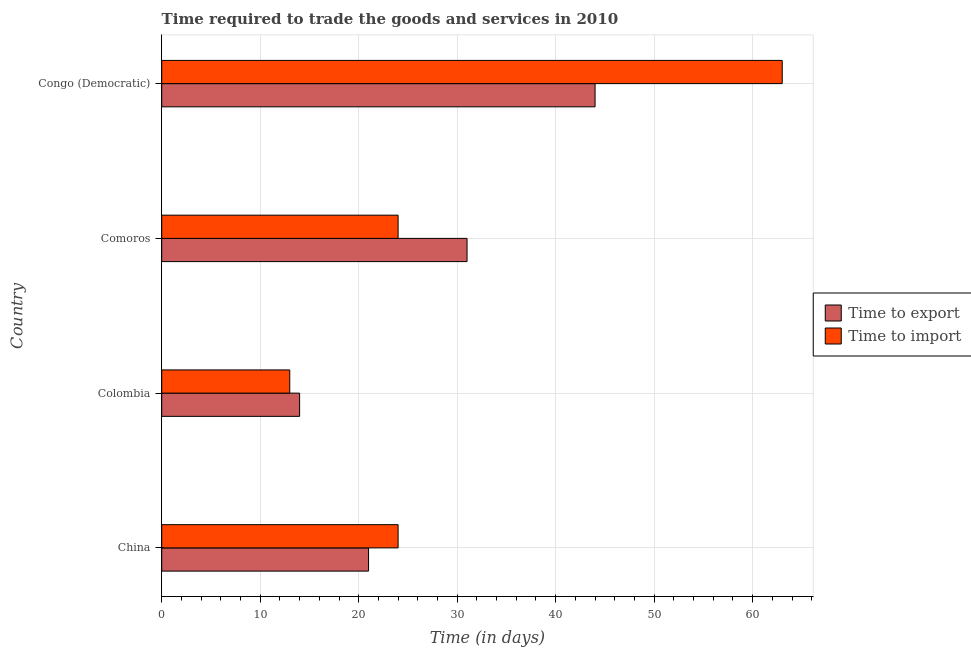How many different coloured bars are there?
Your answer should be compact. 2. Are the number of bars on each tick of the Y-axis equal?
Offer a very short reply. Yes. How many bars are there on the 1st tick from the top?
Ensure brevity in your answer.  2. In how many cases, is the number of bars for a given country not equal to the number of legend labels?
Your response must be concise. 0. Across all countries, what is the maximum time to export?
Give a very brief answer. 44. In which country was the time to export maximum?
Provide a short and direct response. Congo (Democratic). What is the total time to import in the graph?
Make the answer very short. 124. What is the difference between the time to export in Colombia and the time to import in Comoros?
Offer a terse response. -10. What is the ratio of the time to export in China to that in Comoros?
Offer a terse response. 0.68. Is the time to import in China less than that in Congo (Democratic)?
Offer a very short reply. Yes. Is the difference between the time to export in Colombia and Comoros greater than the difference between the time to import in Colombia and Comoros?
Provide a succinct answer. No. What is the difference between the highest and the second highest time to export?
Your answer should be compact. 13. What does the 1st bar from the top in Congo (Democratic) represents?
Provide a succinct answer. Time to import. What does the 1st bar from the bottom in Colombia represents?
Provide a short and direct response. Time to export. How many bars are there?
Keep it short and to the point. 8. Are all the bars in the graph horizontal?
Your answer should be very brief. Yes. How many countries are there in the graph?
Your response must be concise. 4. Does the graph contain grids?
Give a very brief answer. Yes. Where does the legend appear in the graph?
Your answer should be very brief. Center right. How are the legend labels stacked?
Your response must be concise. Vertical. What is the title of the graph?
Your answer should be very brief. Time required to trade the goods and services in 2010. Does "Girls" appear as one of the legend labels in the graph?
Your response must be concise. No. What is the label or title of the X-axis?
Offer a terse response. Time (in days). What is the Time (in days) in Time to import in China?
Your answer should be compact. 24. What is the Time (in days) of Time to export in Colombia?
Give a very brief answer. 14. What is the Time (in days) of Time to import in Colombia?
Offer a terse response. 13. What is the Time (in days) in Time to import in Comoros?
Make the answer very short. 24. What is the Time (in days) in Time to import in Congo (Democratic)?
Make the answer very short. 63. Across all countries, what is the maximum Time (in days) of Time to import?
Your response must be concise. 63. Across all countries, what is the minimum Time (in days) of Time to export?
Provide a succinct answer. 14. What is the total Time (in days) of Time to export in the graph?
Provide a succinct answer. 110. What is the total Time (in days) of Time to import in the graph?
Make the answer very short. 124. What is the difference between the Time (in days) of Time to import in China and that in Colombia?
Ensure brevity in your answer.  11. What is the difference between the Time (in days) of Time to export in China and that in Comoros?
Provide a succinct answer. -10. What is the difference between the Time (in days) in Time to import in China and that in Comoros?
Provide a short and direct response. 0. What is the difference between the Time (in days) in Time to export in China and that in Congo (Democratic)?
Your answer should be compact. -23. What is the difference between the Time (in days) of Time to import in China and that in Congo (Democratic)?
Keep it short and to the point. -39. What is the difference between the Time (in days) in Time to export in Colombia and that in Comoros?
Make the answer very short. -17. What is the difference between the Time (in days) in Time to import in Comoros and that in Congo (Democratic)?
Ensure brevity in your answer.  -39. What is the difference between the Time (in days) in Time to export in China and the Time (in days) in Time to import in Comoros?
Give a very brief answer. -3. What is the difference between the Time (in days) in Time to export in China and the Time (in days) in Time to import in Congo (Democratic)?
Keep it short and to the point. -42. What is the difference between the Time (in days) of Time to export in Colombia and the Time (in days) of Time to import in Comoros?
Provide a short and direct response. -10. What is the difference between the Time (in days) in Time to export in Colombia and the Time (in days) in Time to import in Congo (Democratic)?
Provide a short and direct response. -49. What is the difference between the Time (in days) of Time to export in Comoros and the Time (in days) of Time to import in Congo (Democratic)?
Your answer should be very brief. -32. What is the difference between the Time (in days) of Time to export and Time (in days) of Time to import in Congo (Democratic)?
Ensure brevity in your answer.  -19. What is the ratio of the Time (in days) in Time to export in China to that in Colombia?
Your answer should be very brief. 1.5. What is the ratio of the Time (in days) in Time to import in China to that in Colombia?
Your answer should be very brief. 1.85. What is the ratio of the Time (in days) of Time to export in China to that in Comoros?
Provide a succinct answer. 0.68. What is the ratio of the Time (in days) in Time to export in China to that in Congo (Democratic)?
Offer a terse response. 0.48. What is the ratio of the Time (in days) in Time to import in China to that in Congo (Democratic)?
Your answer should be compact. 0.38. What is the ratio of the Time (in days) in Time to export in Colombia to that in Comoros?
Give a very brief answer. 0.45. What is the ratio of the Time (in days) of Time to import in Colombia to that in Comoros?
Keep it short and to the point. 0.54. What is the ratio of the Time (in days) in Time to export in Colombia to that in Congo (Democratic)?
Provide a succinct answer. 0.32. What is the ratio of the Time (in days) in Time to import in Colombia to that in Congo (Democratic)?
Ensure brevity in your answer.  0.21. What is the ratio of the Time (in days) in Time to export in Comoros to that in Congo (Democratic)?
Provide a short and direct response. 0.7. What is the ratio of the Time (in days) of Time to import in Comoros to that in Congo (Democratic)?
Give a very brief answer. 0.38. What is the difference between the highest and the lowest Time (in days) in Time to export?
Your answer should be compact. 30. 